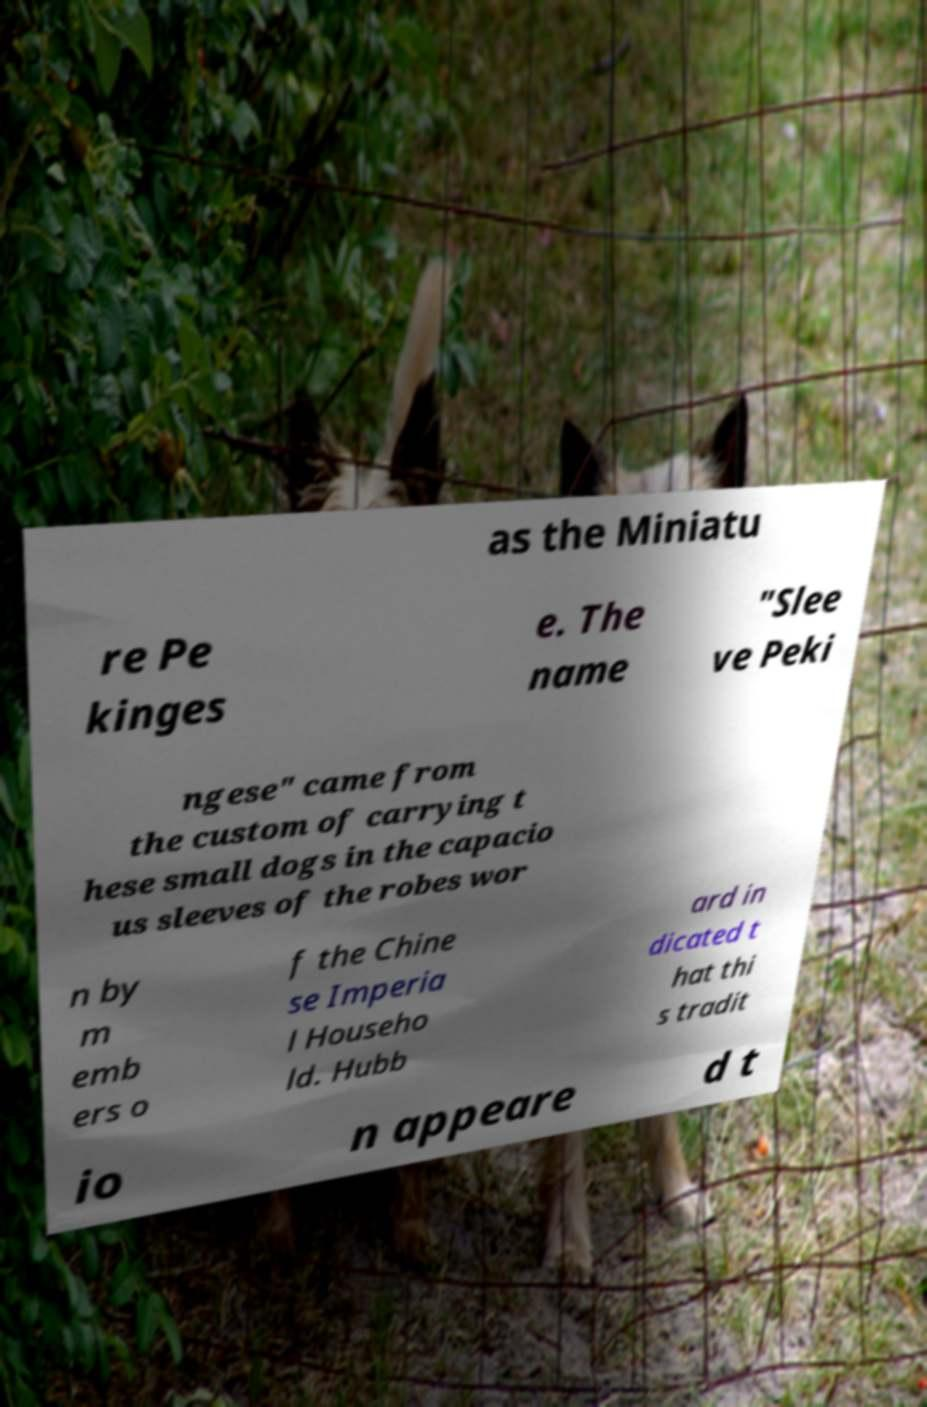For documentation purposes, I need the text within this image transcribed. Could you provide that? as the Miniatu re Pe kinges e. The name "Slee ve Peki ngese" came from the custom of carrying t hese small dogs in the capacio us sleeves of the robes wor n by m emb ers o f the Chine se Imperia l Househo ld. Hubb ard in dicated t hat thi s tradit io n appeare d t 